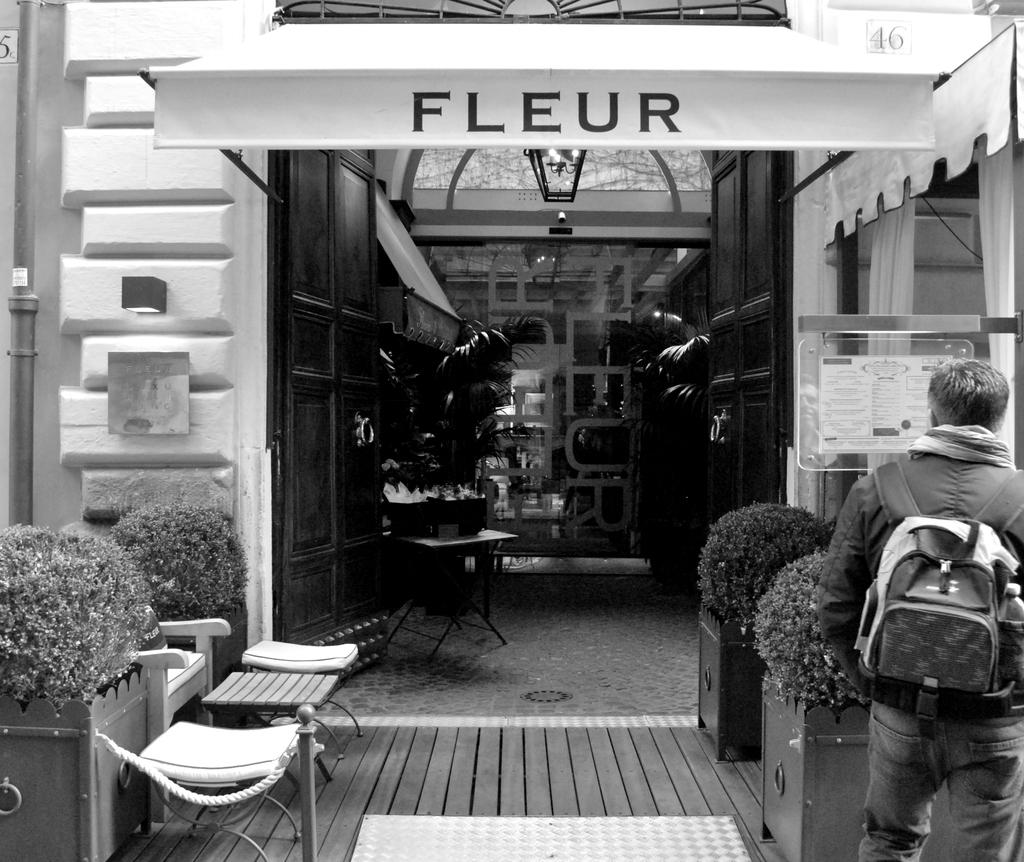What is the color scheme of the image? The image is black and white. Who is present in the image? There is a man in the image. What is the man carrying in the image? The man is carrying a backpack. What type of vegetation is visible in the image? There are plants in the image. What type of furniture is present in the image? There are chairs in the image. What type of structure is visible in the image? There is a building in the image. What object can be seen in the image that might be used for displaying information or announcements? There is a board in the image. How many books can be seen on the fireman's shelf in the image? There is no fireman or shelf with books present in the image. What type of garden is visible in the image? There is no garden visible in the image. 